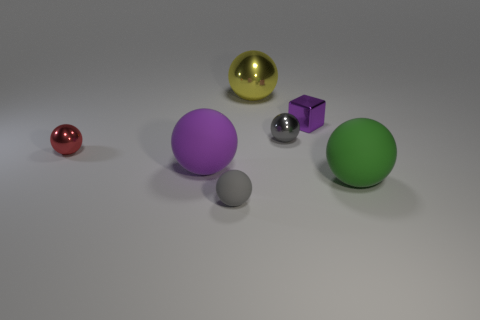There is a tiny gray sphere in front of the purple matte object; what material is it?
Your answer should be very brief. Rubber. Is there anything else that has the same size as the green matte object?
Your answer should be very brief. Yes. There is a purple sphere; are there any tiny spheres left of it?
Offer a very short reply. Yes. What is the shape of the tiny purple shiny thing?
Your response must be concise. Cube. What number of objects are big purple spheres that are on the right side of the red shiny ball or large gray matte cylinders?
Make the answer very short. 1. How many other things are there of the same color as the large metal thing?
Provide a succinct answer. 0. There is a block; does it have the same color as the sphere that is on the right side of the small purple shiny thing?
Keep it short and to the point. No. What is the color of the other tiny rubber thing that is the same shape as the green object?
Your answer should be compact. Gray. Is the yellow thing made of the same material as the gray thing that is left of the yellow object?
Make the answer very short. No. The large metal sphere has what color?
Offer a very short reply. Yellow. 